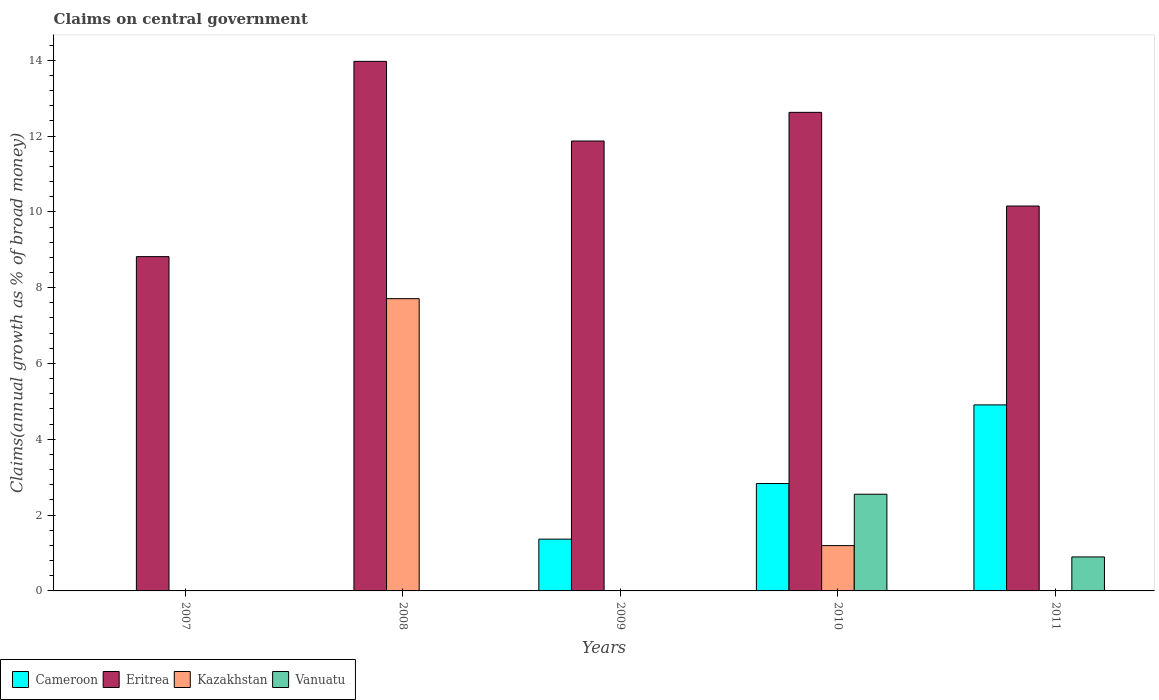How many different coloured bars are there?
Your response must be concise. 4. Are the number of bars per tick equal to the number of legend labels?
Give a very brief answer. No. How many bars are there on the 5th tick from the right?
Give a very brief answer. 1. What is the label of the 3rd group of bars from the left?
Offer a terse response. 2009. What is the percentage of broad money claimed on centeral government in Kazakhstan in 2009?
Provide a short and direct response. 0. Across all years, what is the maximum percentage of broad money claimed on centeral government in Vanuatu?
Your answer should be compact. 2.55. Across all years, what is the minimum percentage of broad money claimed on centeral government in Cameroon?
Keep it short and to the point. 0. In which year was the percentage of broad money claimed on centeral government in Eritrea maximum?
Ensure brevity in your answer.  2008. What is the total percentage of broad money claimed on centeral government in Vanuatu in the graph?
Offer a very short reply. 3.45. What is the difference between the percentage of broad money claimed on centeral government in Kazakhstan in 2008 and that in 2010?
Ensure brevity in your answer.  6.51. What is the difference between the percentage of broad money claimed on centeral government in Eritrea in 2007 and the percentage of broad money claimed on centeral government in Cameroon in 2011?
Offer a terse response. 3.91. What is the average percentage of broad money claimed on centeral government in Eritrea per year?
Offer a very short reply. 11.49. In the year 2010, what is the difference between the percentage of broad money claimed on centeral government in Eritrea and percentage of broad money claimed on centeral government in Kazakhstan?
Ensure brevity in your answer.  11.43. What is the ratio of the percentage of broad money claimed on centeral government in Kazakhstan in 2008 to that in 2010?
Your response must be concise. 6.45. Is the percentage of broad money claimed on centeral government in Eritrea in 2008 less than that in 2009?
Give a very brief answer. No. Is the difference between the percentage of broad money claimed on centeral government in Eritrea in 2008 and 2010 greater than the difference between the percentage of broad money claimed on centeral government in Kazakhstan in 2008 and 2010?
Provide a short and direct response. No. What is the difference between the highest and the second highest percentage of broad money claimed on centeral government in Cameroon?
Provide a short and direct response. 2.07. What is the difference between the highest and the lowest percentage of broad money claimed on centeral government in Cameroon?
Ensure brevity in your answer.  4.91. Is the sum of the percentage of broad money claimed on centeral government in Eritrea in 2008 and 2010 greater than the maximum percentage of broad money claimed on centeral government in Kazakhstan across all years?
Your response must be concise. Yes. Are all the bars in the graph horizontal?
Keep it short and to the point. No. Does the graph contain any zero values?
Give a very brief answer. Yes. Does the graph contain grids?
Your answer should be compact. No. How many legend labels are there?
Keep it short and to the point. 4. How are the legend labels stacked?
Ensure brevity in your answer.  Horizontal. What is the title of the graph?
Ensure brevity in your answer.  Claims on central government. Does "Argentina" appear as one of the legend labels in the graph?
Your response must be concise. No. What is the label or title of the Y-axis?
Your answer should be very brief. Claims(annual growth as % of broad money). What is the Claims(annual growth as % of broad money) of Eritrea in 2007?
Your response must be concise. 8.82. What is the Claims(annual growth as % of broad money) in Eritrea in 2008?
Offer a very short reply. 13.97. What is the Claims(annual growth as % of broad money) in Kazakhstan in 2008?
Offer a very short reply. 7.71. What is the Claims(annual growth as % of broad money) in Vanuatu in 2008?
Offer a very short reply. 0. What is the Claims(annual growth as % of broad money) in Cameroon in 2009?
Ensure brevity in your answer.  1.37. What is the Claims(annual growth as % of broad money) of Eritrea in 2009?
Offer a very short reply. 11.87. What is the Claims(annual growth as % of broad money) in Kazakhstan in 2009?
Your answer should be very brief. 0. What is the Claims(annual growth as % of broad money) in Cameroon in 2010?
Offer a very short reply. 2.83. What is the Claims(annual growth as % of broad money) of Eritrea in 2010?
Your response must be concise. 12.62. What is the Claims(annual growth as % of broad money) of Kazakhstan in 2010?
Your response must be concise. 1.2. What is the Claims(annual growth as % of broad money) of Vanuatu in 2010?
Your response must be concise. 2.55. What is the Claims(annual growth as % of broad money) in Cameroon in 2011?
Make the answer very short. 4.91. What is the Claims(annual growth as % of broad money) in Eritrea in 2011?
Give a very brief answer. 10.15. What is the Claims(annual growth as % of broad money) in Vanuatu in 2011?
Your answer should be compact. 0.9. Across all years, what is the maximum Claims(annual growth as % of broad money) of Cameroon?
Make the answer very short. 4.91. Across all years, what is the maximum Claims(annual growth as % of broad money) in Eritrea?
Your response must be concise. 13.97. Across all years, what is the maximum Claims(annual growth as % of broad money) in Kazakhstan?
Your response must be concise. 7.71. Across all years, what is the maximum Claims(annual growth as % of broad money) in Vanuatu?
Give a very brief answer. 2.55. Across all years, what is the minimum Claims(annual growth as % of broad money) of Eritrea?
Offer a terse response. 8.82. Across all years, what is the minimum Claims(annual growth as % of broad money) in Vanuatu?
Offer a terse response. 0. What is the total Claims(annual growth as % of broad money) of Cameroon in the graph?
Offer a terse response. 9.11. What is the total Claims(annual growth as % of broad money) in Eritrea in the graph?
Provide a succinct answer. 57.44. What is the total Claims(annual growth as % of broad money) in Kazakhstan in the graph?
Your answer should be very brief. 8.91. What is the total Claims(annual growth as % of broad money) in Vanuatu in the graph?
Make the answer very short. 3.45. What is the difference between the Claims(annual growth as % of broad money) of Eritrea in 2007 and that in 2008?
Offer a very short reply. -5.15. What is the difference between the Claims(annual growth as % of broad money) of Eritrea in 2007 and that in 2009?
Provide a succinct answer. -3.05. What is the difference between the Claims(annual growth as % of broad money) in Eritrea in 2007 and that in 2010?
Your response must be concise. -3.81. What is the difference between the Claims(annual growth as % of broad money) in Eritrea in 2007 and that in 2011?
Your answer should be very brief. -1.33. What is the difference between the Claims(annual growth as % of broad money) in Eritrea in 2008 and that in 2009?
Ensure brevity in your answer.  2.1. What is the difference between the Claims(annual growth as % of broad money) in Eritrea in 2008 and that in 2010?
Ensure brevity in your answer.  1.35. What is the difference between the Claims(annual growth as % of broad money) of Kazakhstan in 2008 and that in 2010?
Your answer should be compact. 6.51. What is the difference between the Claims(annual growth as % of broad money) in Eritrea in 2008 and that in 2011?
Provide a short and direct response. 3.82. What is the difference between the Claims(annual growth as % of broad money) in Cameroon in 2009 and that in 2010?
Provide a short and direct response. -1.47. What is the difference between the Claims(annual growth as % of broad money) of Eritrea in 2009 and that in 2010?
Offer a terse response. -0.76. What is the difference between the Claims(annual growth as % of broad money) of Cameroon in 2009 and that in 2011?
Offer a very short reply. -3.54. What is the difference between the Claims(annual growth as % of broad money) in Eritrea in 2009 and that in 2011?
Offer a terse response. 1.72. What is the difference between the Claims(annual growth as % of broad money) in Cameroon in 2010 and that in 2011?
Make the answer very short. -2.07. What is the difference between the Claims(annual growth as % of broad money) in Eritrea in 2010 and that in 2011?
Offer a very short reply. 2.47. What is the difference between the Claims(annual growth as % of broad money) in Vanuatu in 2010 and that in 2011?
Provide a short and direct response. 1.65. What is the difference between the Claims(annual growth as % of broad money) in Eritrea in 2007 and the Claims(annual growth as % of broad money) in Kazakhstan in 2008?
Offer a very short reply. 1.11. What is the difference between the Claims(annual growth as % of broad money) of Eritrea in 2007 and the Claims(annual growth as % of broad money) of Kazakhstan in 2010?
Provide a short and direct response. 7.62. What is the difference between the Claims(annual growth as % of broad money) of Eritrea in 2007 and the Claims(annual growth as % of broad money) of Vanuatu in 2010?
Your answer should be compact. 6.27. What is the difference between the Claims(annual growth as % of broad money) in Eritrea in 2007 and the Claims(annual growth as % of broad money) in Vanuatu in 2011?
Ensure brevity in your answer.  7.92. What is the difference between the Claims(annual growth as % of broad money) in Eritrea in 2008 and the Claims(annual growth as % of broad money) in Kazakhstan in 2010?
Your answer should be compact. 12.77. What is the difference between the Claims(annual growth as % of broad money) of Eritrea in 2008 and the Claims(annual growth as % of broad money) of Vanuatu in 2010?
Your answer should be compact. 11.42. What is the difference between the Claims(annual growth as % of broad money) in Kazakhstan in 2008 and the Claims(annual growth as % of broad money) in Vanuatu in 2010?
Your response must be concise. 5.16. What is the difference between the Claims(annual growth as % of broad money) in Eritrea in 2008 and the Claims(annual growth as % of broad money) in Vanuatu in 2011?
Your answer should be very brief. 13.07. What is the difference between the Claims(annual growth as % of broad money) in Kazakhstan in 2008 and the Claims(annual growth as % of broad money) in Vanuatu in 2011?
Ensure brevity in your answer.  6.81. What is the difference between the Claims(annual growth as % of broad money) of Cameroon in 2009 and the Claims(annual growth as % of broad money) of Eritrea in 2010?
Ensure brevity in your answer.  -11.26. What is the difference between the Claims(annual growth as % of broad money) in Cameroon in 2009 and the Claims(annual growth as % of broad money) in Kazakhstan in 2010?
Your answer should be very brief. 0.17. What is the difference between the Claims(annual growth as % of broad money) of Cameroon in 2009 and the Claims(annual growth as % of broad money) of Vanuatu in 2010?
Keep it short and to the point. -1.18. What is the difference between the Claims(annual growth as % of broad money) of Eritrea in 2009 and the Claims(annual growth as % of broad money) of Kazakhstan in 2010?
Your answer should be compact. 10.67. What is the difference between the Claims(annual growth as % of broad money) of Eritrea in 2009 and the Claims(annual growth as % of broad money) of Vanuatu in 2010?
Offer a very short reply. 9.32. What is the difference between the Claims(annual growth as % of broad money) of Cameroon in 2009 and the Claims(annual growth as % of broad money) of Eritrea in 2011?
Ensure brevity in your answer.  -8.79. What is the difference between the Claims(annual growth as % of broad money) in Cameroon in 2009 and the Claims(annual growth as % of broad money) in Vanuatu in 2011?
Ensure brevity in your answer.  0.47. What is the difference between the Claims(annual growth as % of broad money) of Eritrea in 2009 and the Claims(annual growth as % of broad money) of Vanuatu in 2011?
Keep it short and to the point. 10.97. What is the difference between the Claims(annual growth as % of broad money) of Cameroon in 2010 and the Claims(annual growth as % of broad money) of Eritrea in 2011?
Provide a short and direct response. -7.32. What is the difference between the Claims(annual growth as % of broad money) in Cameroon in 2010 and the Claims(annual growth as % of broad money) in Vanuatu in 2011?
Your response must be concise. 1.94. What is the difference between the Claims(annual growth as % of broad money) of Eritrea in 2010 and the Claims(annual growth as % of broad money) of Vanuatu in 2011?
Keep it short and to the point. 11.73. What is the difference between the Claims(annual growth as % of broad money) of Kazakhstan in 2010 and the Claims(annual growth as % of broad money) of Vanuatu in 2011?
Keep it short and to the point. 0.3. What is the average Claims(annual growth as % of broad money) of Cameroon per year?
Make the answer very short. 1.82. What is the average Claims(annual growth as % of broad money) in Eritrea per year?
Offer a terse response. 11.49. What is the average Claims(annual growth as % of broad money) in Kazakhstan per year?
Make the answer very short. 1.78. What is the average Claims(annual growth as % of broad money) of Vanuatu per year?
Make the answer very short. 0.69. In the year 2008, what is the difference between the Claims(annual growth as % of broad money) in Eritrea and Claims(annual growth as % of broad money) in Kazakhstan?
Provide a succinct answer. 6.26. In the year 2009, what is the difference between the Claims(annual growth as % of broad money) in Cameroon and Claims(annual growth as % of broad money) in Eritrea?
Provide a short and direct response. -10.5. In the year 2010, what is the difference between the Claims(annual growth as % of broad money) in Cameroon and Claims(annual growth as % of broad money) in Eritrea?
Offer a very short reply. -9.79. In the year 2010, what is the difference between the Claims(annual growth as % of broad money) in Cameroon and Claims(annual growth as % of broad money) in Kazakhstan?
Provide a short and direct response. 1.64. In the year 2010, what is the difference between the Claims(annual growth as % of broad money) of Cameroon and Claims(annual growth as % of broad money) of Vanuatu?
Give a very brief answer. 0.28. In the year 2010, what is the difference between the Claims(annual growth as % of broad money) of Eritrea and Claims(annual growth as % of broad money) of Kazakhstan?
Provide a succinct answer. 11.43. In the year 2010, what is the difference between the Claims(annual growth as % of broad money) in Eritrea and Claims(annual growth as % of broad money) in Vanuatu?
Ensure brevity in your answer.  10.07. In the year 2010, what is the difference between the Claims(annual growth as % of broad money) of Kazakhstan and Claims(annual growth as % of broad money) of Vanuatu?
Make the answer very short. -1.36. In the year 2011, what is the difference between the Claims(annual growth as % of broad money) of Cameroon and Claims(annual growth as % of broad money) of Eritrea?
Your response must be concise. -5.25. In the year 2011, what is the difference between the Claims(annual growth as % of broad money) in Cameroon and Claims(annual growth as % of broad money) in Vanuatu?
Provide a short and direct response. 4.01. In the year 2011, what is the difference between the Claims(annual growth as % of broad money) in Eritrea and Claims(annual growth as % of broad money) in Vanuatu?
Your response must be concise. 9.26. What is the ratio of the Claims(annual growth as % of broad money) in Eritrea in 2007 to that in 2008?
Provide a succinct answer. 0.63. What is the ratio of the Claims(annual growth as % of broad money) of Eritrea in 2007 to that in 2009?
Give a very brief answer. 0.74. What is the ratio of the Claims(annual growth as % of broad money) in Eritrea in 2007 to that in 2010?
Provide a succinct answer. 0.7. What is the ratio of the Claims(annual growth as % of broad money) in Eritrea in 2007 to that in 2011?
Ensure brevity in your answer.  0.87. What is the ratio of the Claims(annual growth as % of broad money) of Eritrea in 2008 to that in 2009?
Make the answer very short. 1.18. What is the ratio of the Claims(annual growth as % of broad money) of Eritrea in 2008 to that in 2010?
Your answer should be very brief. 1.11. What is the ratio of the Claims(annual growth as % of broad money) in Kazakhstan in 2008 to that in 2010?
Offer a terse response. 6.45. What is the ratio of the Claims(annual growth as % of broad money) in Eritrea in 2008 to that in 2011?
Give a very brief answer. 1.38. What is the ratio of the Claims(annual growth as % of broad money) of Cameroon in 2009 to that in 2010?
Make the answer very short. 0.48. What is the ratio of the Claims(annual growth as % of broad money) of Eritrea in 2009 to that in 2010?
Offer a very short reply. 0.94. What is the ratio of the Claims(annual growth as % of broad money) in Cameroon in 2009 to that in 2011?
Your answer should be compact. 0.28. What is the ratio of the Claims(annual growth as % of broad money) of Eritrea in 2009 to that in 2011?
Offer a very short reply. 1.17. What is the ratio of the Claims(annual growth as % of broad money) in Cameroon in 2010 to that in 2011?
Provide a succinct answer. 0.58. What is the ratio of the Claims(annual growth as % of broad money) of Eritrea in 2010 to that in 2011?
Provide a short and direct response. 1.24. What is the ratio of the Claims(annual growth as % of broad money) of Vanuatu in 2010 to that in 2011?
Your answer should be compact. 2.84. What is the difference between the highest and the second highest Claims(annual growth as % of broad money) of Cameroon?
Give a very brief answer. 2.07. What is the difference between the highest and the second highest Claims(annual growth as % of broad money) of Eritrea?
Provide a short and direct response. 1.35. What is the difference between the highest and the lowest Claims(annual growth as % of broad money) of Cameroon?
Offer a terse response. 4.91. What is the difference between the highest and the lowest Claims(annual growth as % of broad money) of Eritrea?
Your answer should be compact. 5.15. What is the difference between the highest and the lowest Claims(annual growth as % of broad money) in Kazakhstan?
Make the answer very short. 7.71. What is the difference between the highest and the lowest Claims(annual growth as % of broad money) of Vanuatu?
Ensure brevity in your answer.  2.55. 